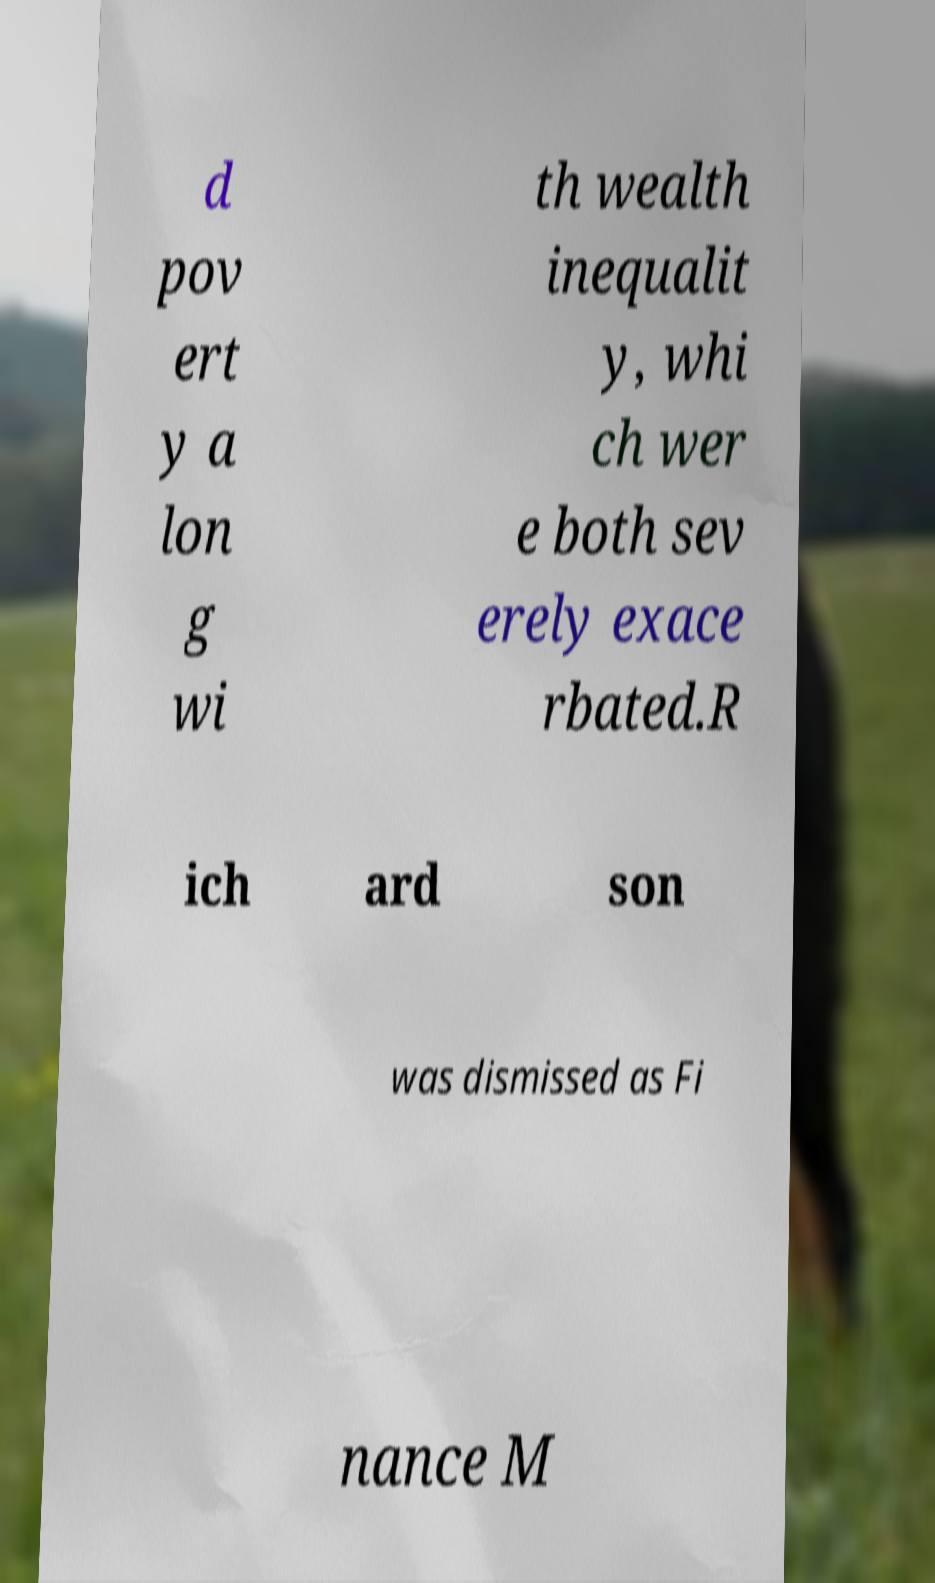Please identify and transcribe the text found in this image. d pov ert y a lon g wi th wealth inequalit y, whi ch wer e both sev erely exace rbated.R ich ard son was dismissed as Fi nance M 